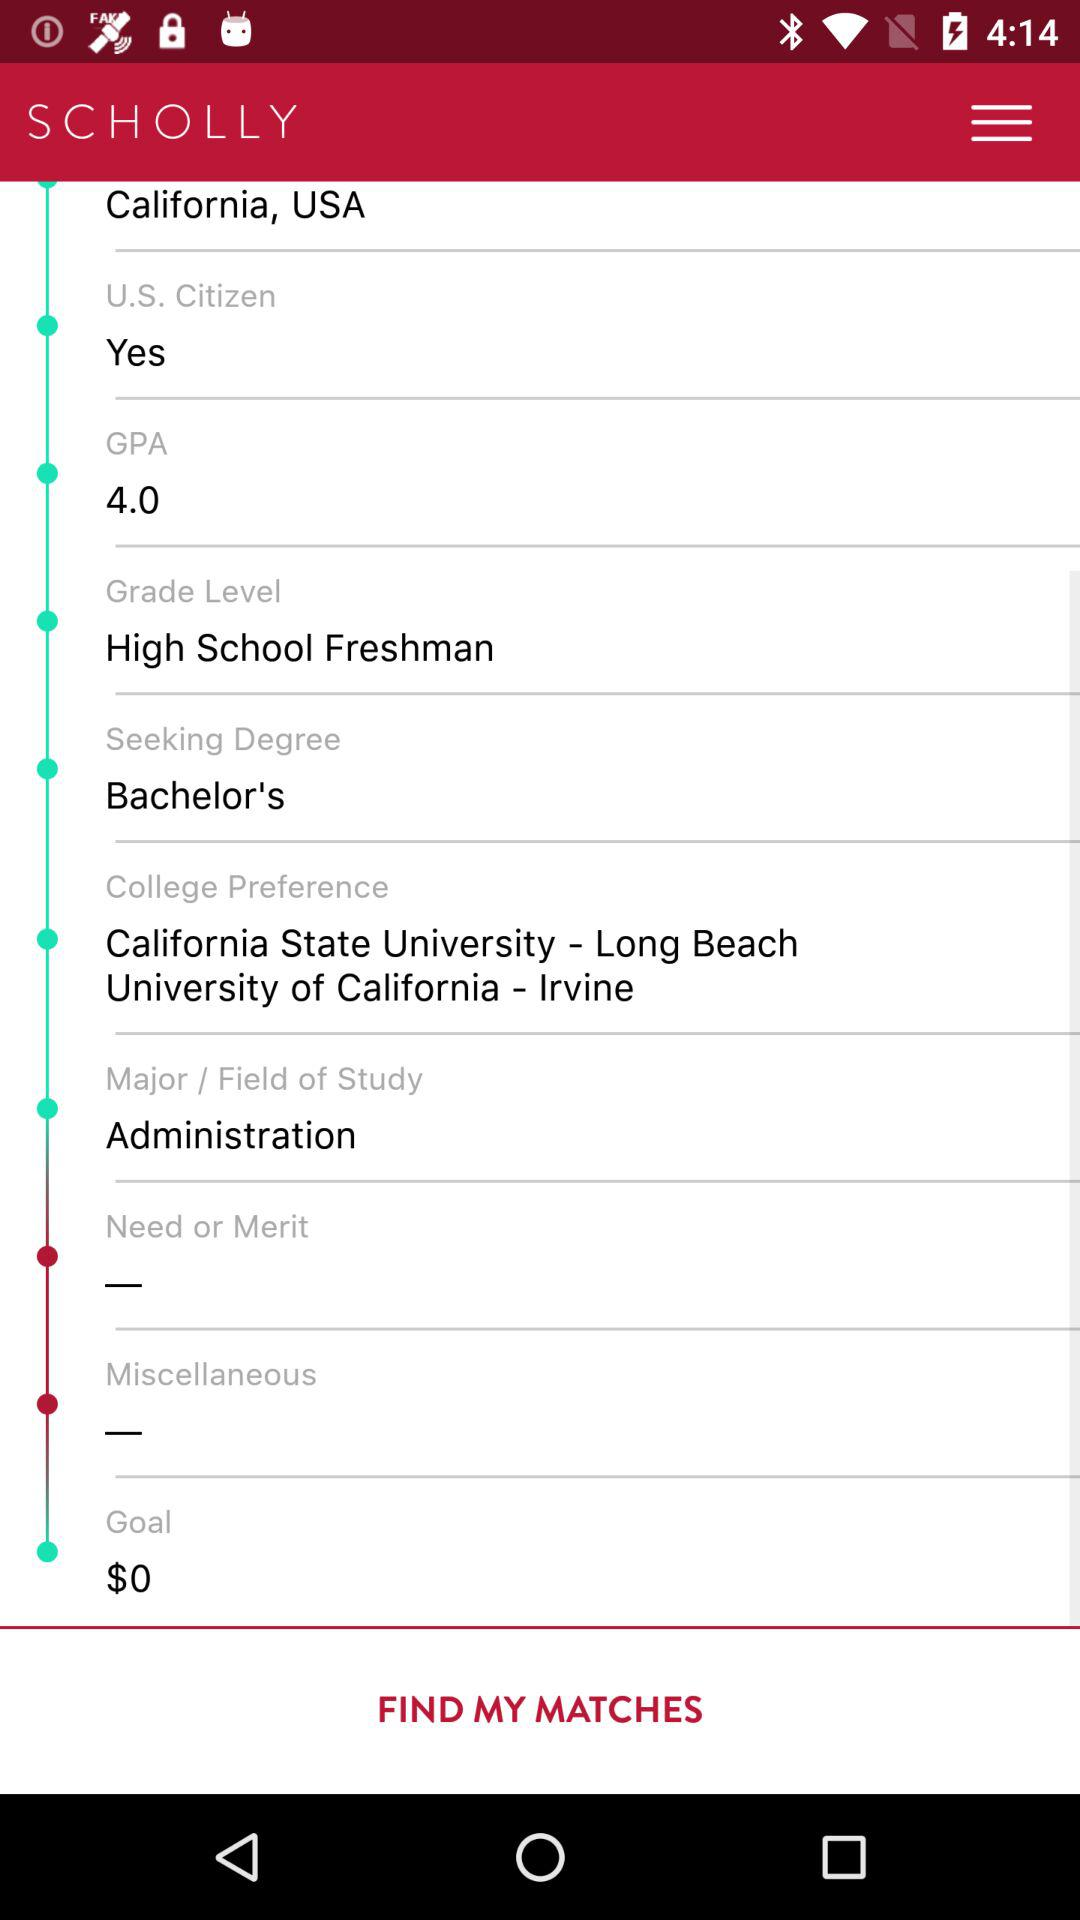What is the country name? The country name is the USA. 